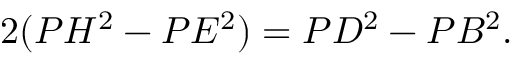<formula> <loc_0><loc_0><loc_500><loc_500>2 ( P H ^ { 2 } - P E ^ { 2 } ) = P D ^ { 2 } - P B ^ { 2 } .</formula> 